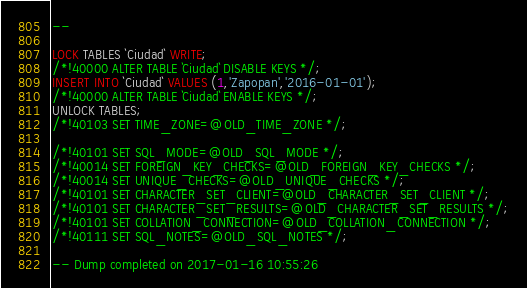Convert code to text. <code><loc_0><loc_0><loc_500><loc_500><_SQL_>--

LOCK TABLES `Ciudad` WRITE;
/*!40000 ALTER TABLE `Ciudad` DISABLE KEYS */;
INSERT INTO `Ciudad` VALUES (1,'Zapopan','2016-01-01');
/*!40000 ALTER TABLE `Ciudad` ENABLE KEYS */;
UNLOCK TABLES;
/*!40103 SET TIME_ZONE=@OLD_TIME_ZONE */;

/*!40101 SET SQL_MODE=@OLD_SQL_MODE */;
/*!40014 SET FOREIGN_KEY_CHECKS=@OLD_FOREIGN_KEY_CHECKS */;
/*!40014 SET UNIQUE_CHECKS=@OLD_UNIQUE_CHECKS */;
/*!40101 SET CHARACTER_SET_CLIENT=@OLD_CHARACTER_SET_CLIENT */;
/*!40101 SET CHARACTER_SET_RESULTS=@OLD_CHARACTER_SET_RESULTS */;
/*!40101 SET COLLATION_CONNECTION=@OLD_COLLATION_CONNECTION */;
/*!40111 SET SQL_NOTES=@OLD_SQL_NOTES */;

-- Dump completed on 2017-01-16 10:55:26
</code> 